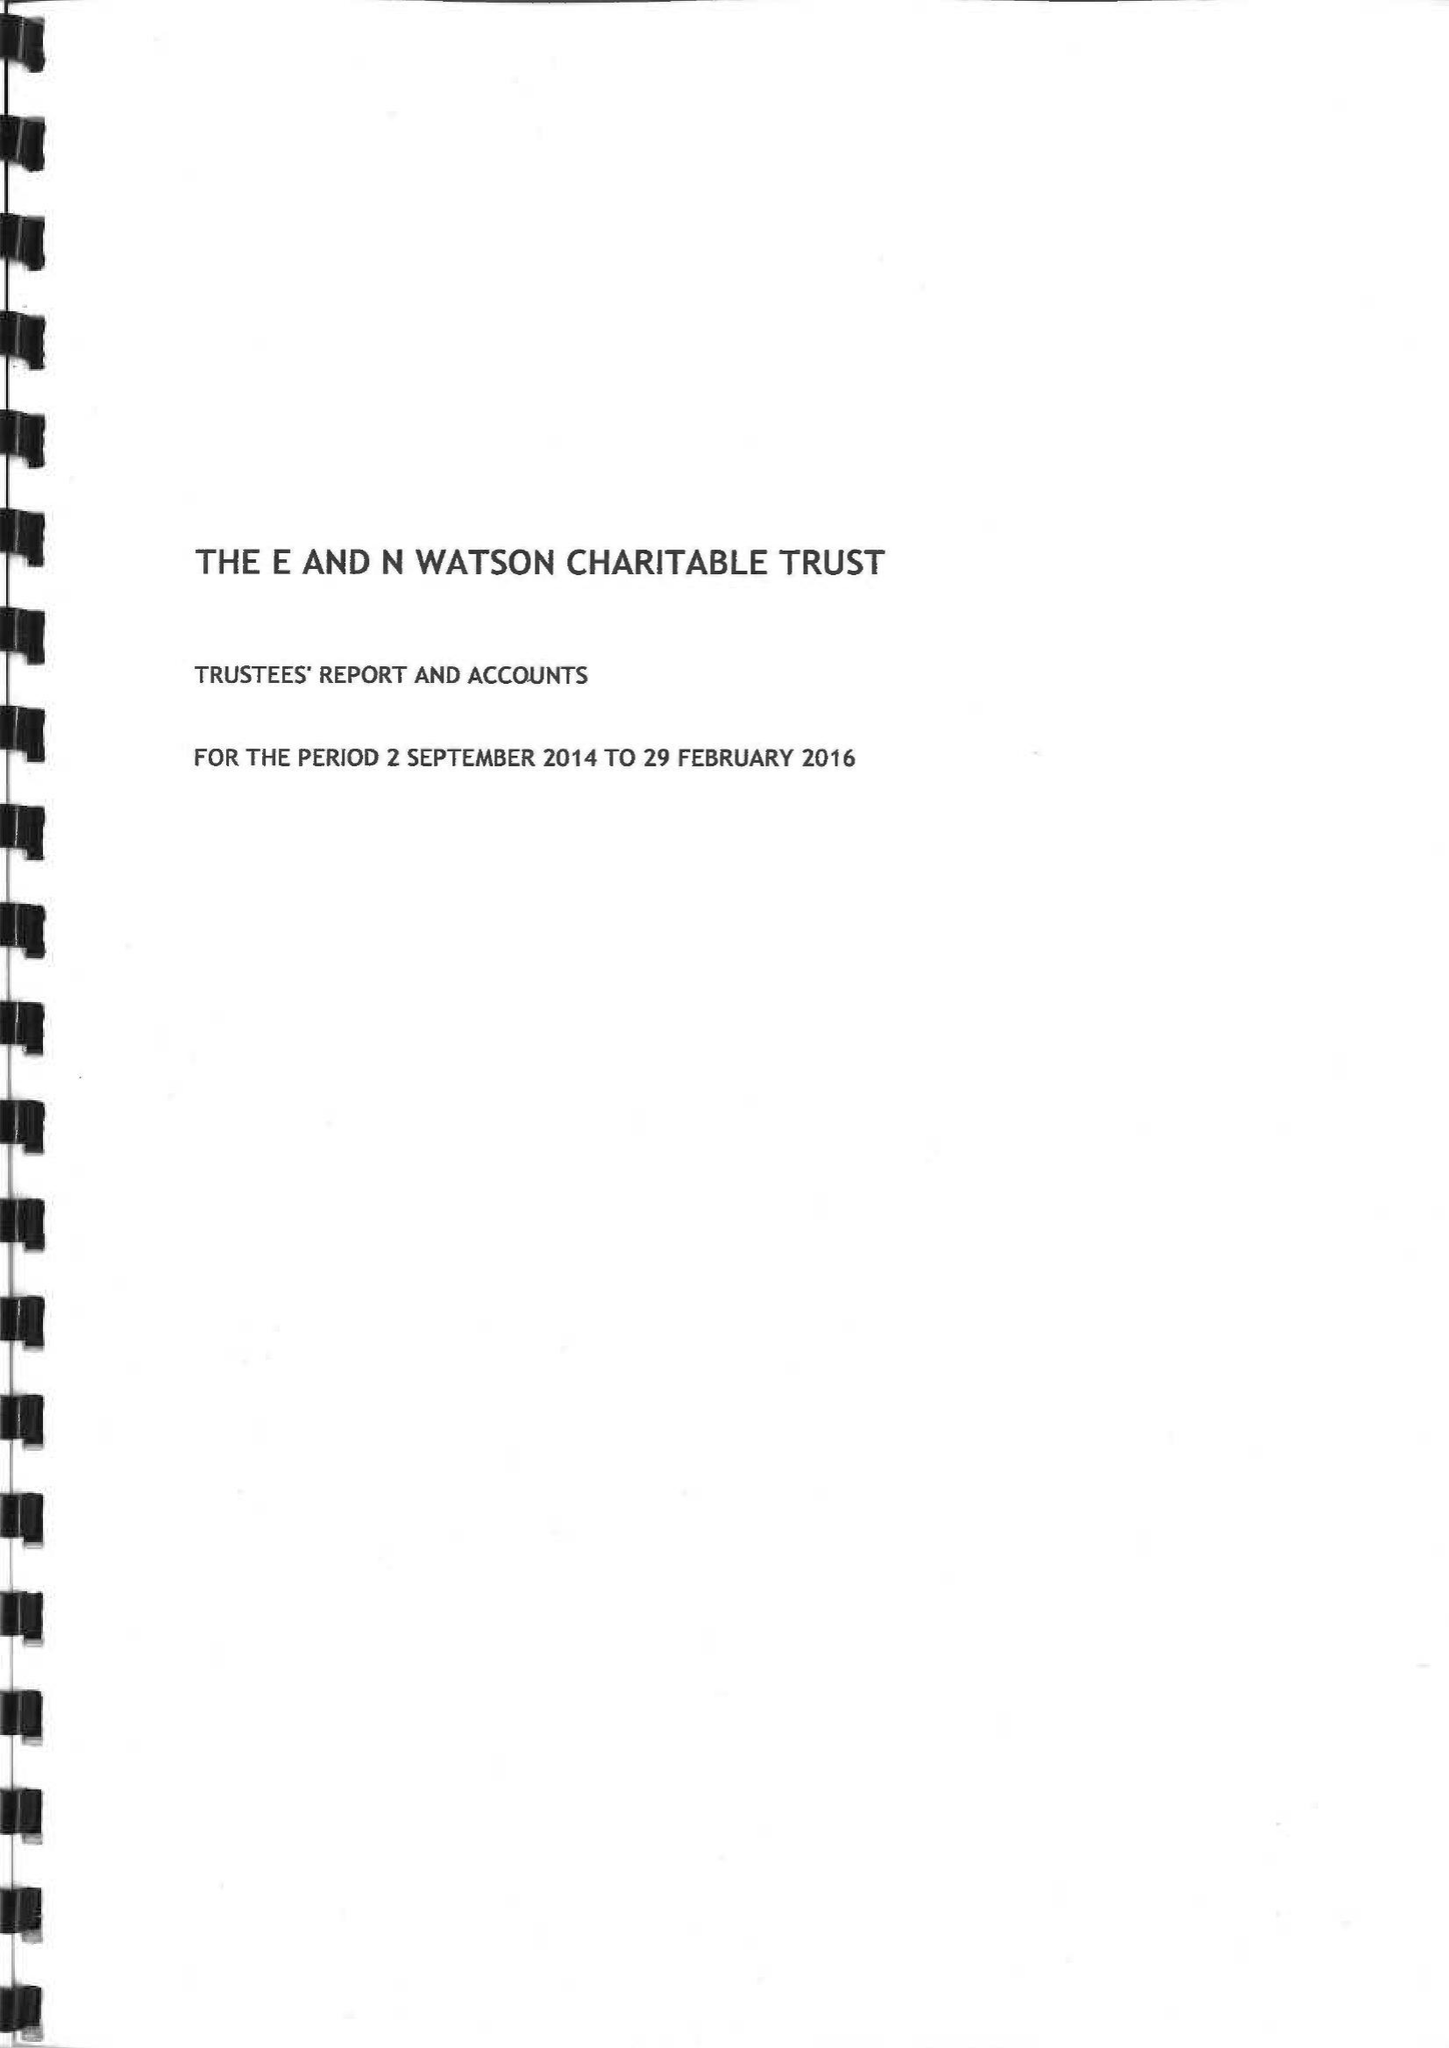What is the value for the charity_number?
Answer the question using a single word or phrase. 1159344 